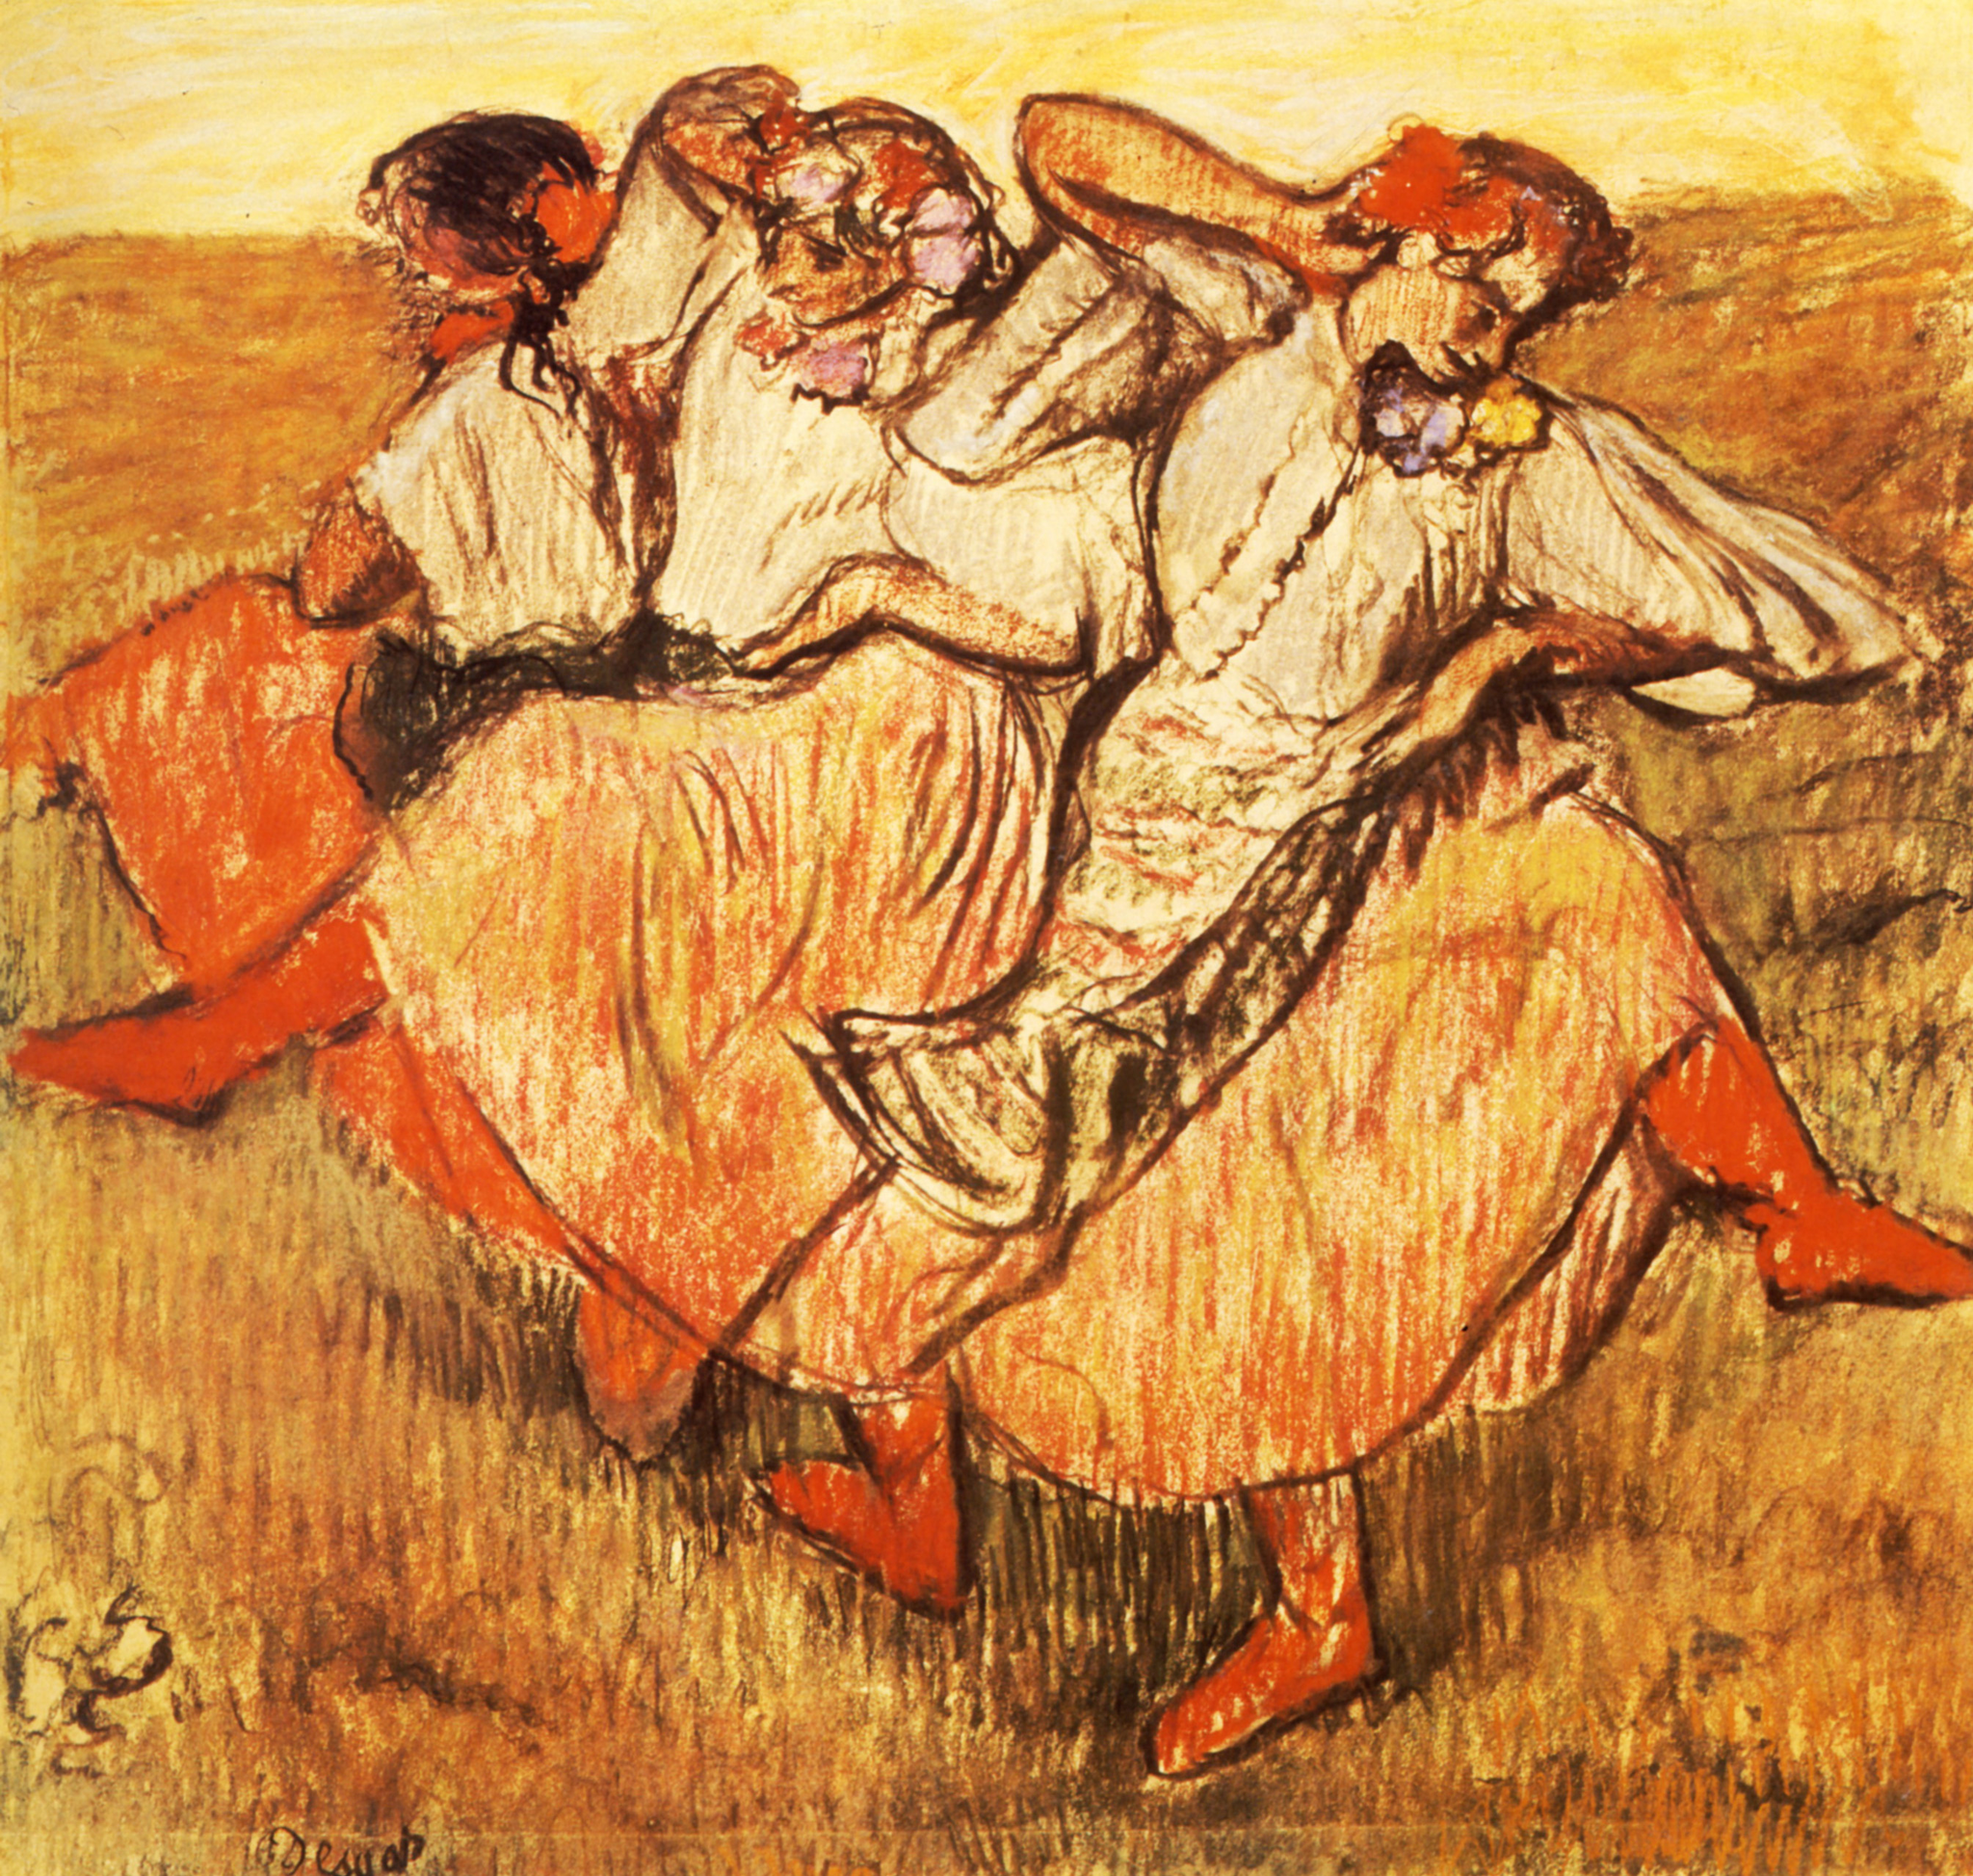Can you discuss the style of the painting and the era it might belong to? This painting is emblematic of the Impressionist style that emerged in the late 19th century. The technique emphasizes quick, visible brushstrokes that blend colors directly on the canvas and capture the essence of the subject rather than the minute details. This style was revolutionary at its time for its departure from the meticulous realism that was favored in academic painting. It often depicted modern life, landscapes, and scenes of leisure with a focus on the play of light and its changing qualities. 